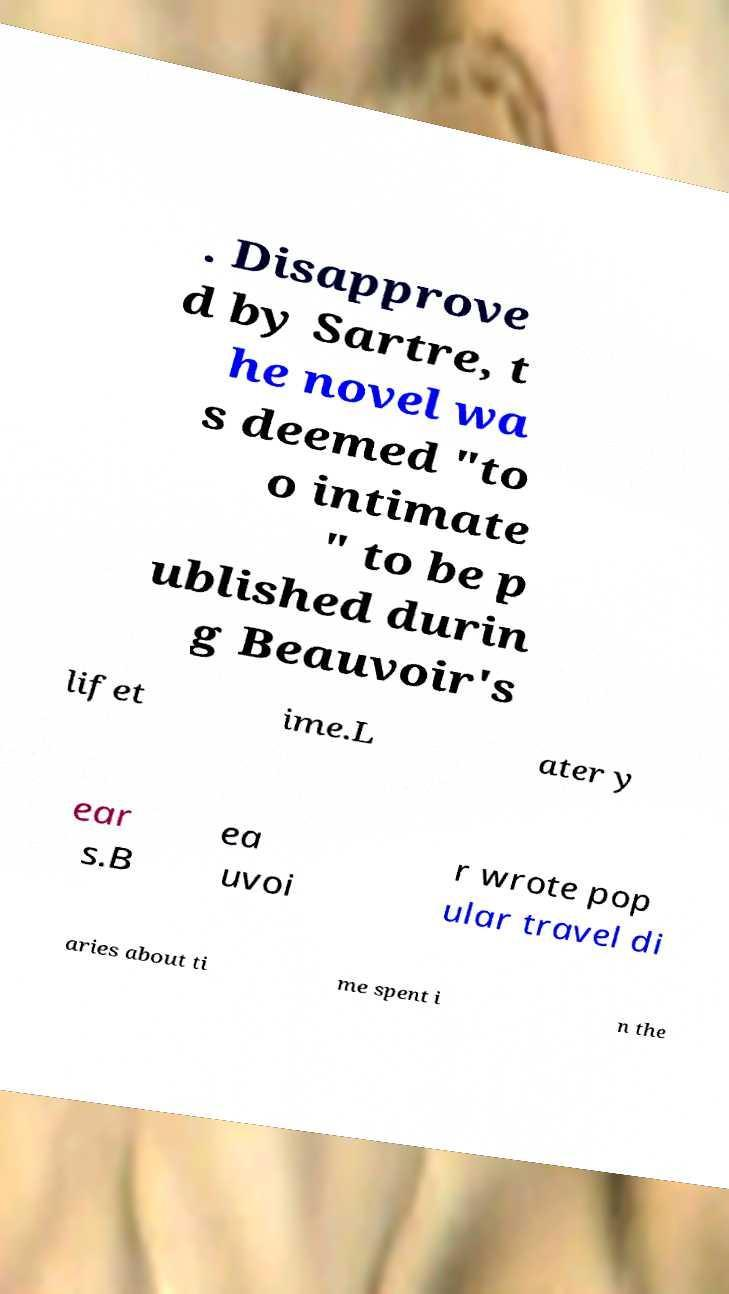There's text embedded in this image that I need extracted. Can you transcribe it verbatim? . Disapprove d by Sartre, t he novel wa s deemed "to o intimate " to be p ublished durin g Beauvoir's lifet ime.L ater y ear s.B ea uvoi r wrote pop ular travel di aries about ti me spent i n the 